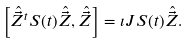Convert formula to latex. <formula><loc_0><loc_0><loc_500><loc_500>\left [ \hat { \vec { Z } } ^ { t } S ( t ) \hat { \vec { Z } } , \hat { \vec { Z } } \right ] = \imath J S ( t ) \hat { \vec { Z } } .</formula> 